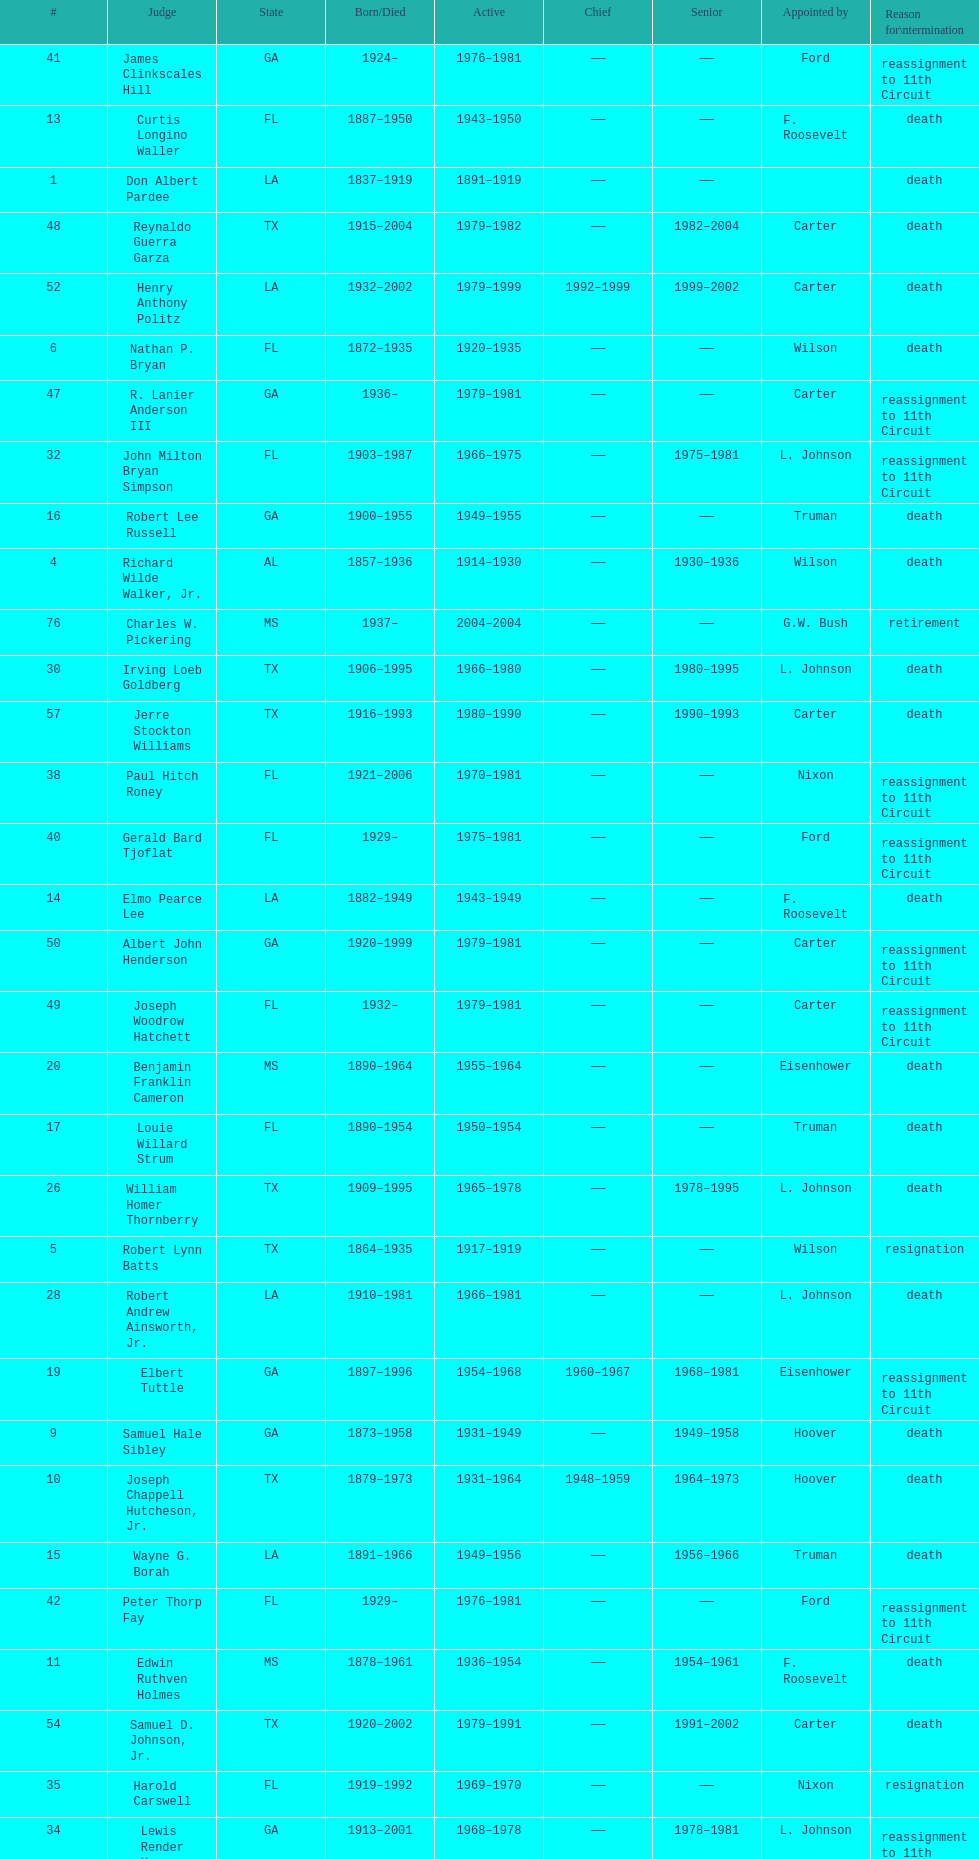Who was the first judge appointed from georgia? Alexander Campbell King. 